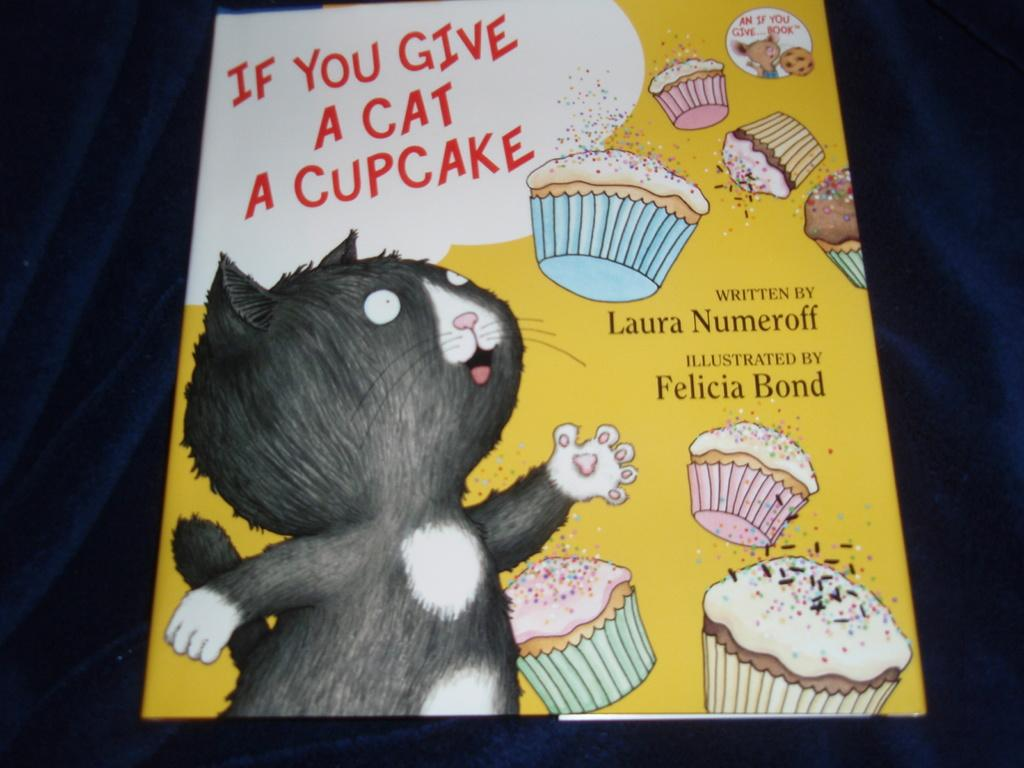What type of animal is depicted in the cartoon image in the picture? There is a cartoon image of a cat in the image. What is the color of the board that has food items depicted on it? The board is yellow. What can be found on the object besides the food items? There is text written on the object. How would you describe the overall lighting in the image? The background of the image is dark. What is the tax rate for the food items depicted on the yellow color board in the image? There is no information about tax rates in the image, as it only shows a cartoon cat and food items on a yellow board with text. How many times does the cat turn around in the image? The cat does not move or turn around in the image; it is a static cartoon image. 